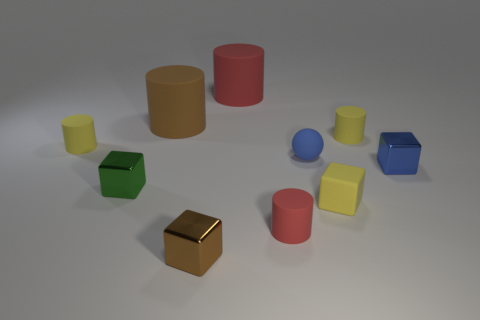Subtract 2 cylinders. How many cylinders are left? 3 Subtract all gray cylinders. Subtract all red cubes. How many cylinders are left? 5 Subtract all balls. How many objects are left? 9 Add 2 spheres. How many spheres are left? 3 Add 5 blue balls. How many blue balls exist? 6 Subtract 0 gray cylinders. How many objects are left? 10 Subtract all red rubber objects. Subtract all small yellow rubber cubes. How many objects are left? 7 